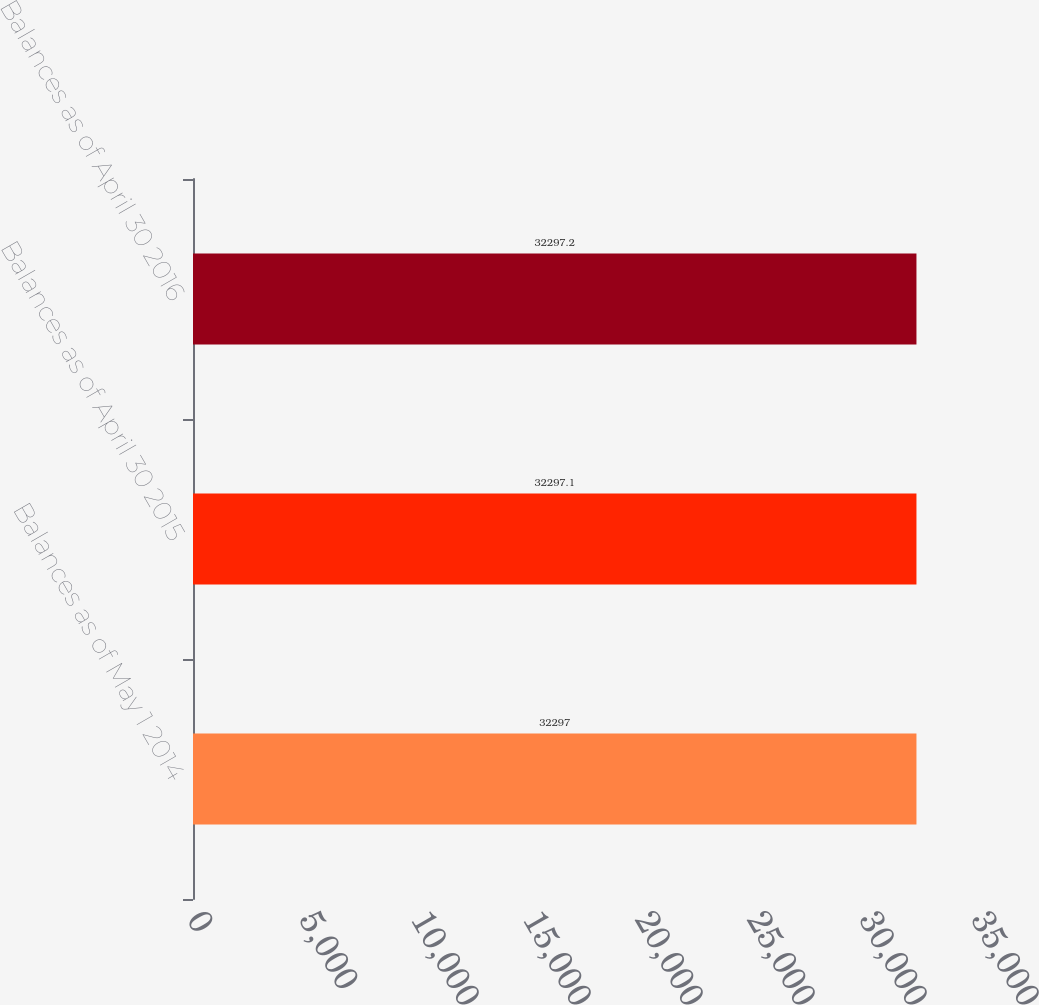Convert chart. <chart><loc_0><loc_0><loc_500><loc_500><bar_chart><fcel>Balances as of May 1 2014<fcel>Balances as of April 30 2015<fcel>Balances as of April 30 2016<nl><fcel>32297<fcel>32297.1<fcel>32297.2<nl></chart> 